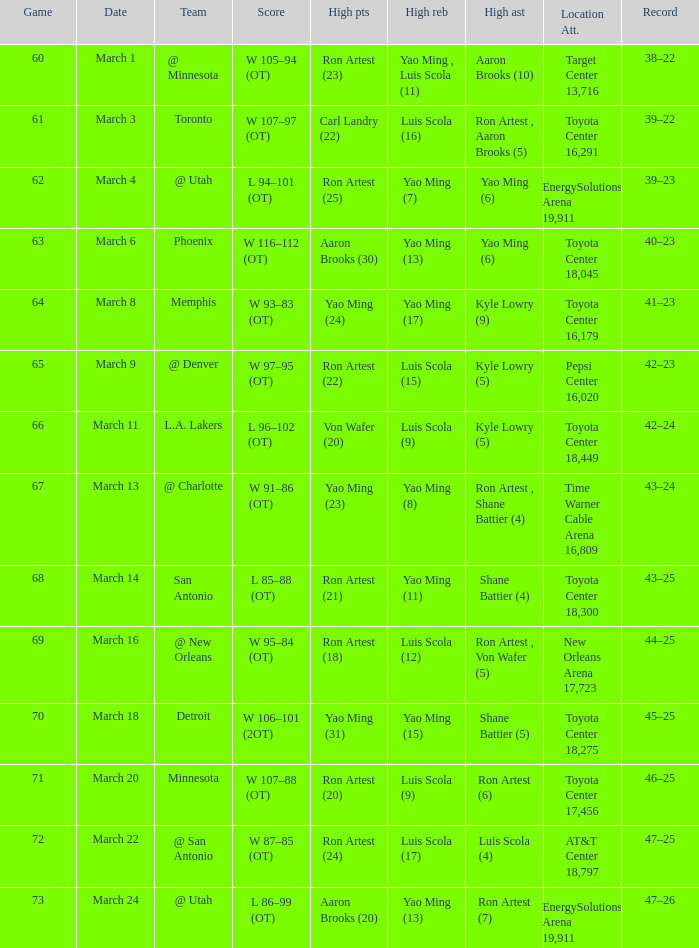Who earned the most points during game 72? Ron Artest (24). 